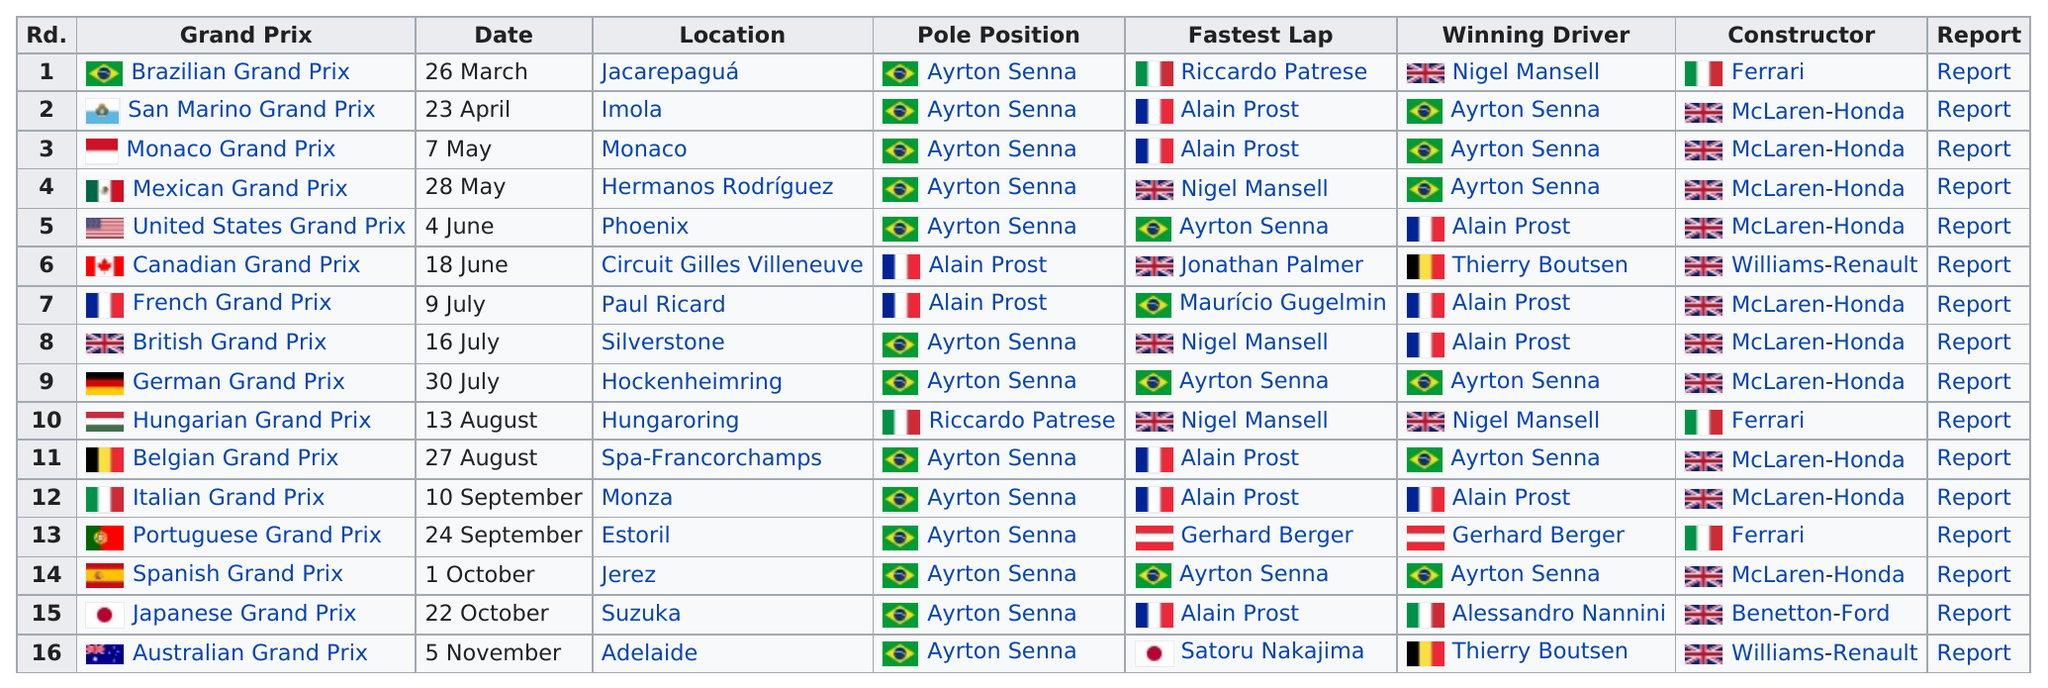Identify some key points in this picture. Ayrton Senna was the teammate of Prost, who won the drivers title in 1986. Ayrton Senna achieved 13 pole positions during his illustrious career as a Formula One driver. In the history of McLaren-Honda partnership, the team achieved an impressive run of four consecutive victories. The Japanese Grand Prix was the only time that Benneton-Ford secured victory in a Grand Prix. There were 5 races before Alain Prost won a pole position. 